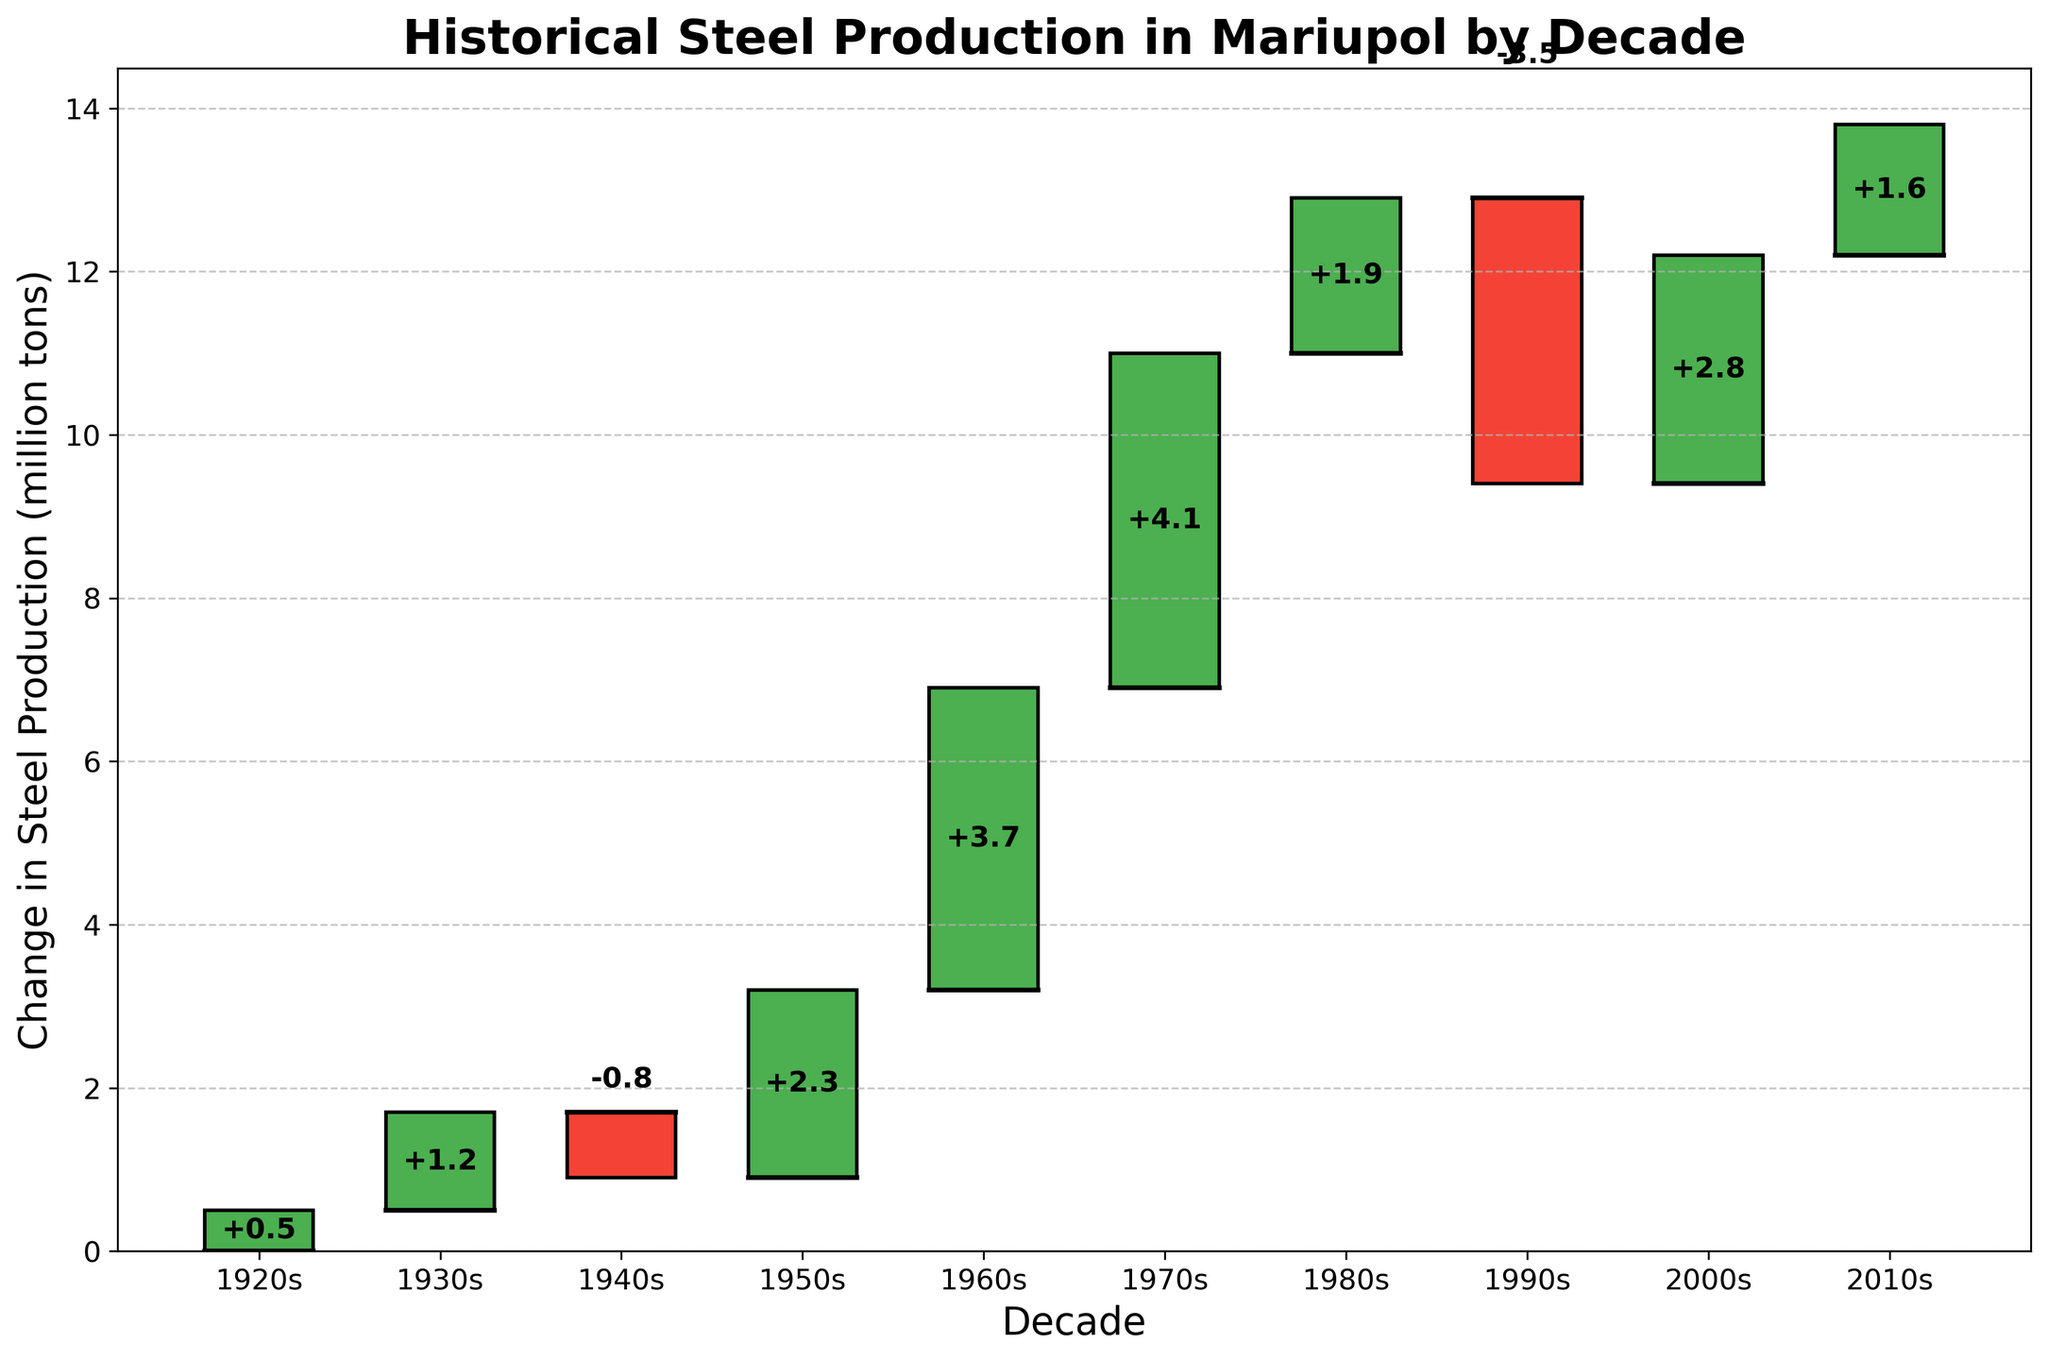What is the title of the chart? The title of the chart is displayed at the top and reads "Historical Steel Production in Mariupol by Decade."
Answer: Historical Steel Production in Mariupol by Decade How many decades are displayed in the chart? By counting the data points along the x-axis, we see that there are 10 decades displayed in the chart.
Answer: 10 Which decade experienced the largest increase in steel production? By observing the height of the bars above the x-axis, the 1970s has the highest bar, indicating the largest increase in steel production.
Answer: 1970s What is the overall change in steel production from the 1920s to 2010s? The cumulative change is represented by the top of the last bar. By summing the changes from each decade: 0.5 + 1.2 - 0.8 + 2.3 + 3.7 + 4.1 + 1.9 - 3.5 + 2.8 + 1.6 = 13.8 million tons.
Answer: 13.8 million tons Which decades experienced a decrease in steel production? The bars below the x-axis indicate a decrease. The 1940s and 1990s both have bars extending downward, showing decreases in these decades.
Answer: 1940s and 1990s What was the total increase in steel production during the decades with positive changes? Sum the positive changes (0.5, 1.2, 2.3, 3.7, 4.1, 1.9, 2.8, and 1.6): 0.5 + 1.2 + 2.3 + 3.7 + 4.1 + 1.9 + 2.8 + 1.6 = 18.1 million tons.
Answer: 18.1 million tons What was the total decrease in steel production during the decades with negative changes? Sum the negative changes (-0.8 and -3.5): -0.8 + (-3.5) = -4.3 million tons.
Answer: -4.3 million tons How did steel production change from the 1980s to the 1990s? Compare the values of the bars for these two decades. The 1980s had an increase of 1.9 million tons, and the 1990s had a decrease of 3.5 million tons. The change would be 1.9 - 3.5 = -1.6 million tons.
Answer: -1.6 million tons Which decade marks the first instance of a decrease in steel production? The first bar below the x-axis appears in the 1940s, indicating a decrease in steel production for the first time.
Answer: 1940s 